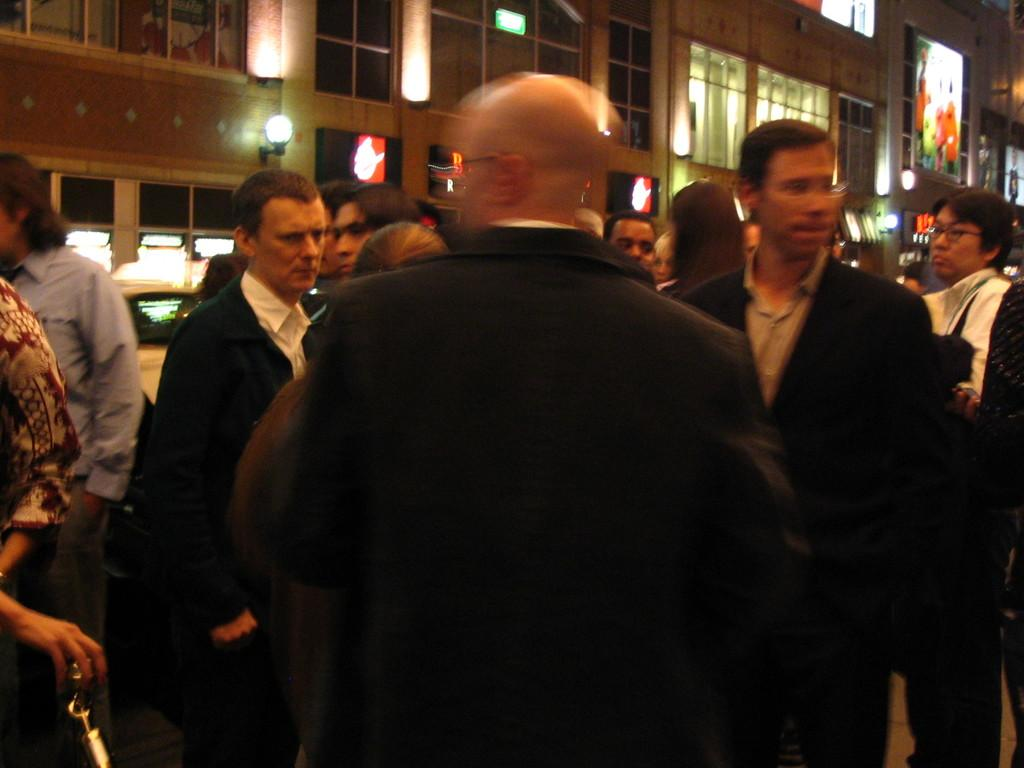How many people are in the image? There is a group of people in the image, but the exact number is not specified. What are the people wearing? The people in the image are wearing clothes. Where are the people standing in relation to the building? The people are standing in front of a building. What can be seen on the wall in the image? There is a light on the wall in the image. What type of coast can be seen in the image? There is no coast visible in the image; it features a group of people standing in front of a building. How does the stomach of the person in the center of the image look? The image does not provide enough detail to determine the appearance of any individual's stomach. 